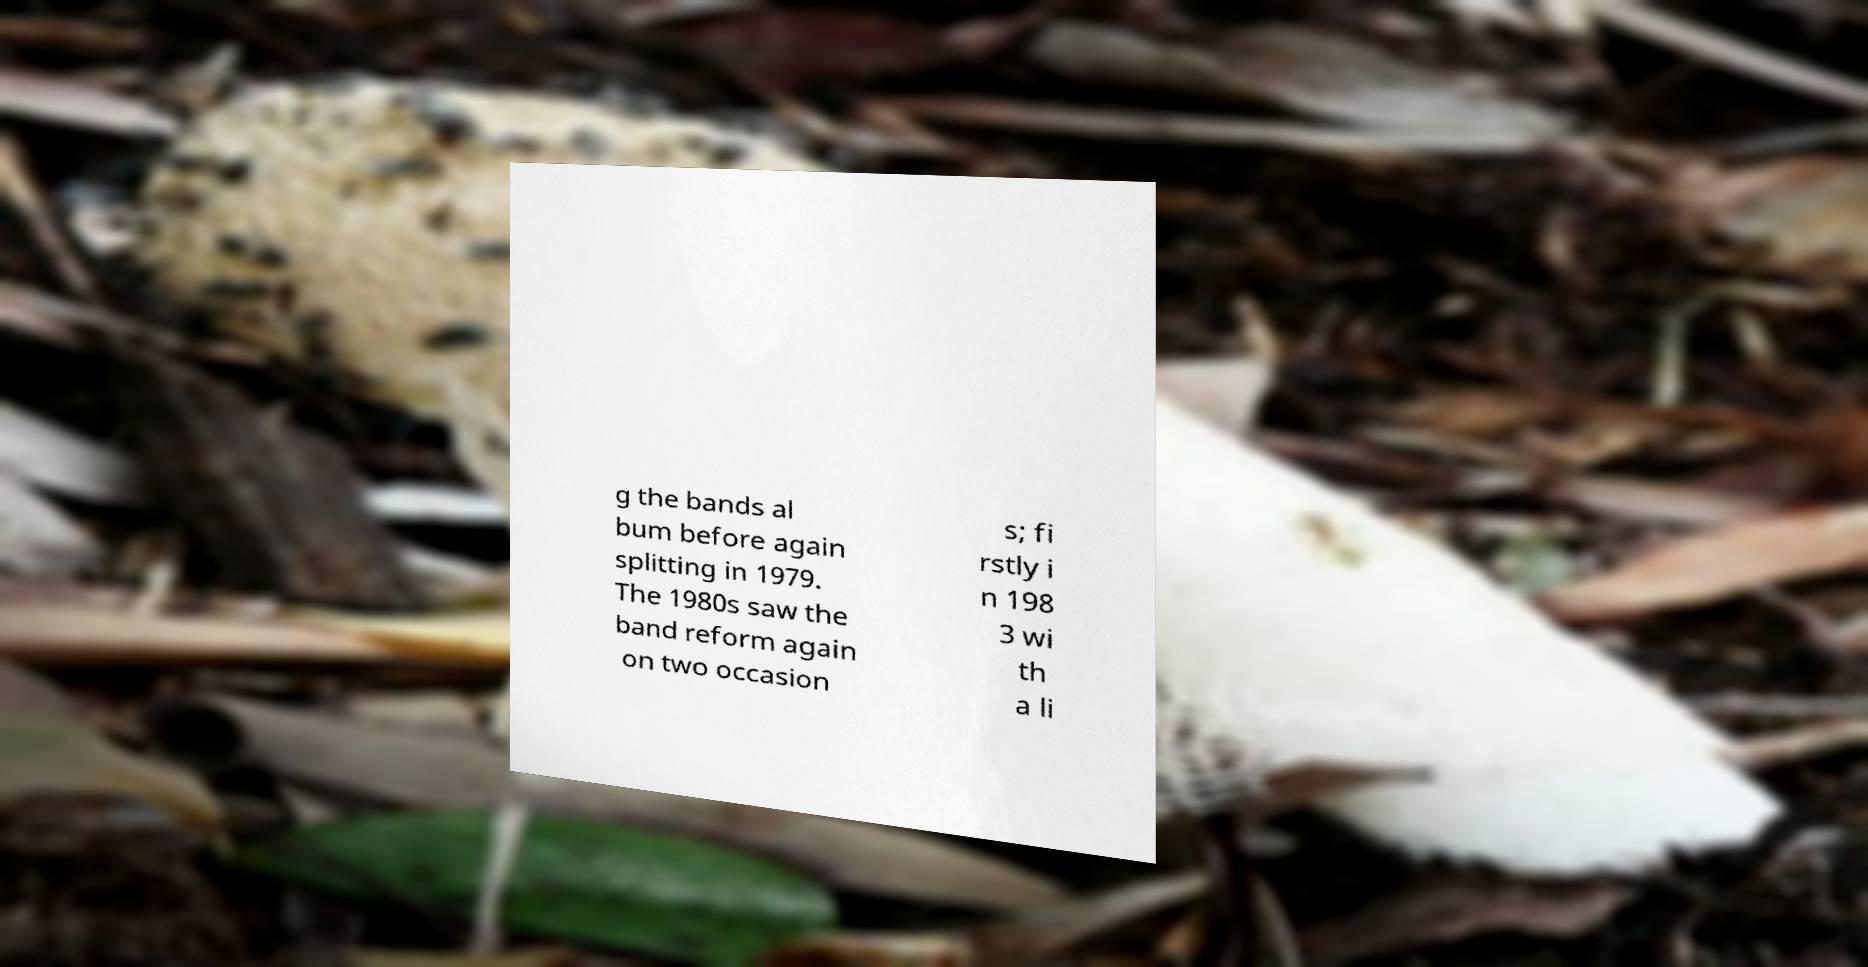Can you accurately transcribe the text from the provided image for me? g the bands al bum before again splitting in 1979. The 1980s saw the band reform again on two occasion s; fi rstly i n 198 3 wi th a li 